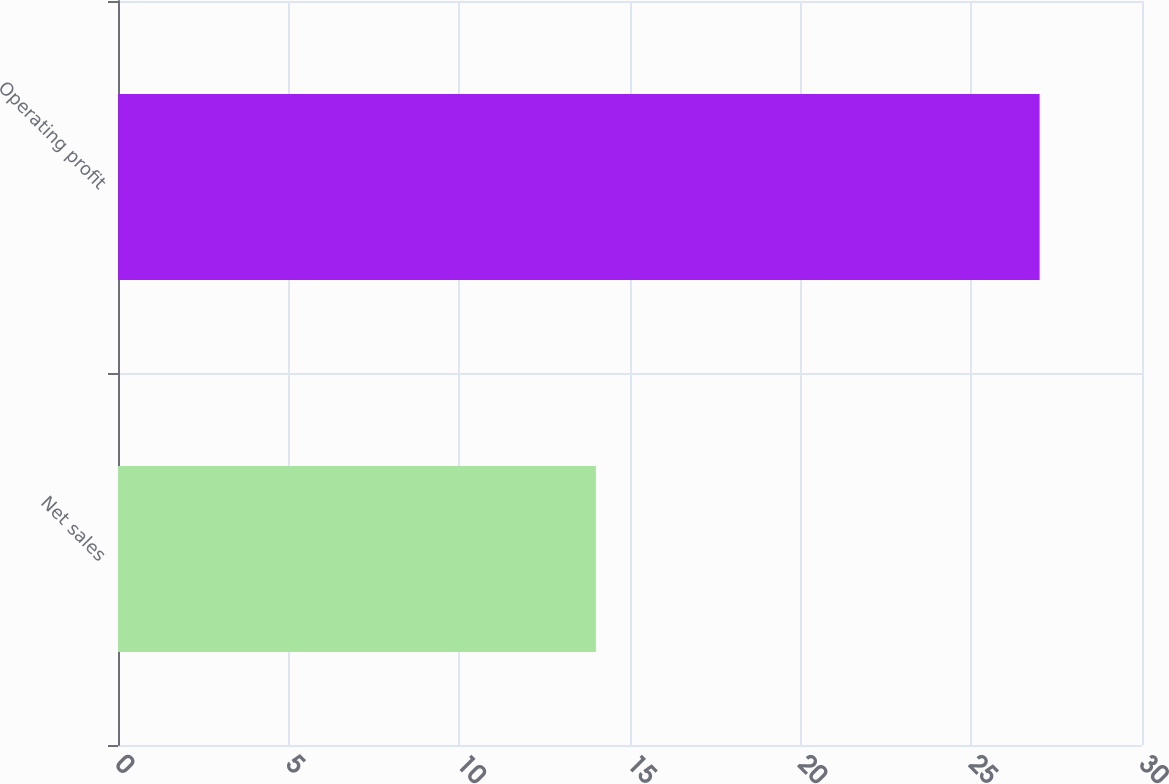Convert chart to OTSL. <chart><loc_0><loc_0><loc_500><loc_500><bar_chart><fcel>Net sales<fcel>Operating profit<nl><fcel>14<fcel>27<nl></chart> 